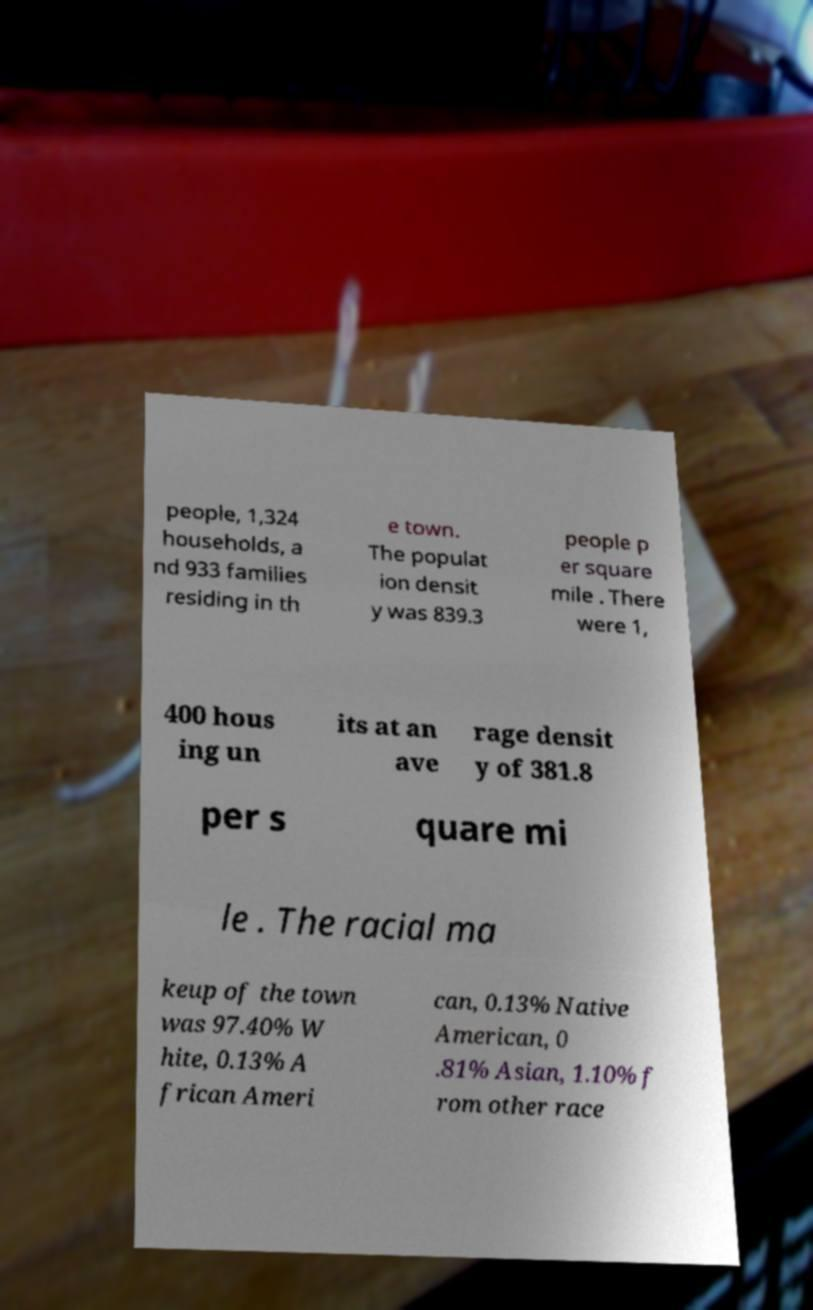Please identify and transcribe the text found in this image. people, 1,324 households, a nd 933 families residing in th e town. The populat ion densit y was 839.3 people p er square mile . There were 1, 400 hous ing un its at an ave rage densit y of 381.8 per s quare mi le . The racial ma keup of the town was 97.40% W hite, 0.13% A frican Ameri can, 0.13% Native American, 0 .81% Asian, 1.10% f rom other race 